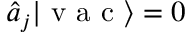Convert formula to latex. <formula><loc_0><loc_0><loc_500><loc_500>\hat { a } _ { j } | v a c \rangle = 0</formula> 